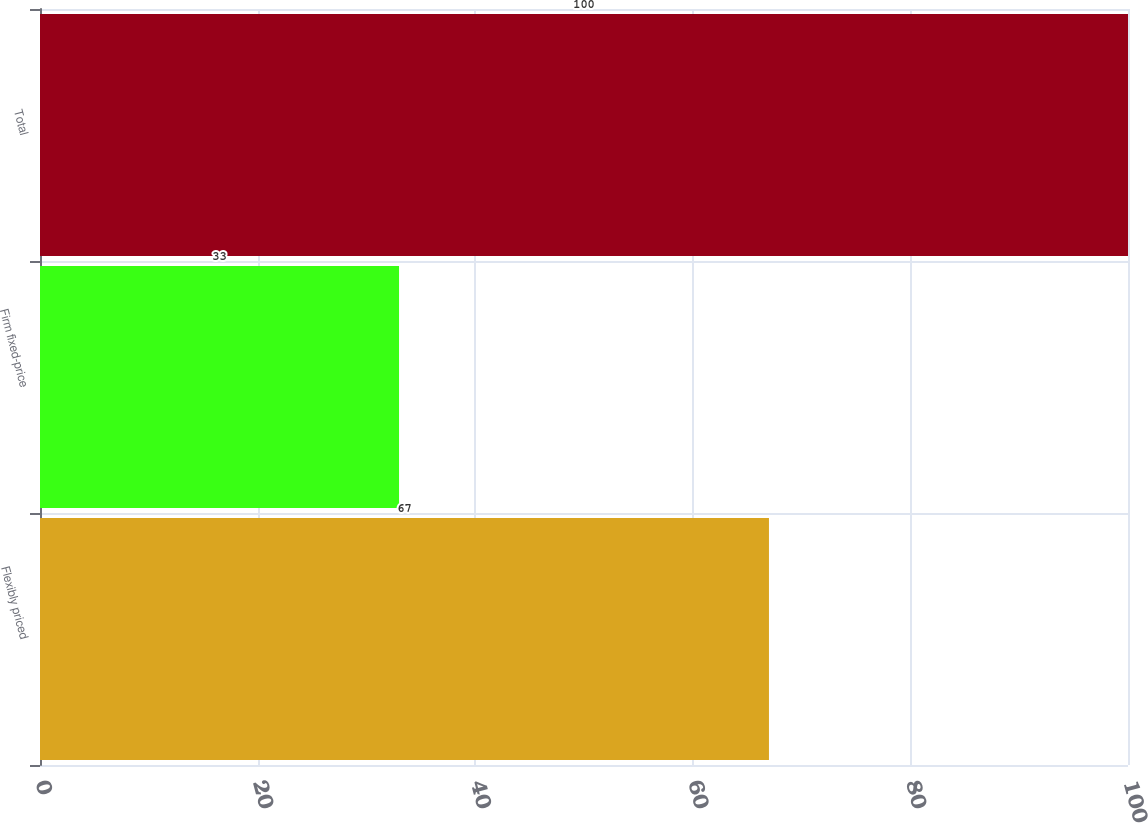Convert chart to OTSL. <chart><loc_0><loc_0><loc_500><loc_500><bar_chart><fcel>Flexibly priced<fcel>Firm fixed-price<fcel>Total<nl><fcel>67<fcel>33<fcel>100<nl></chart> 